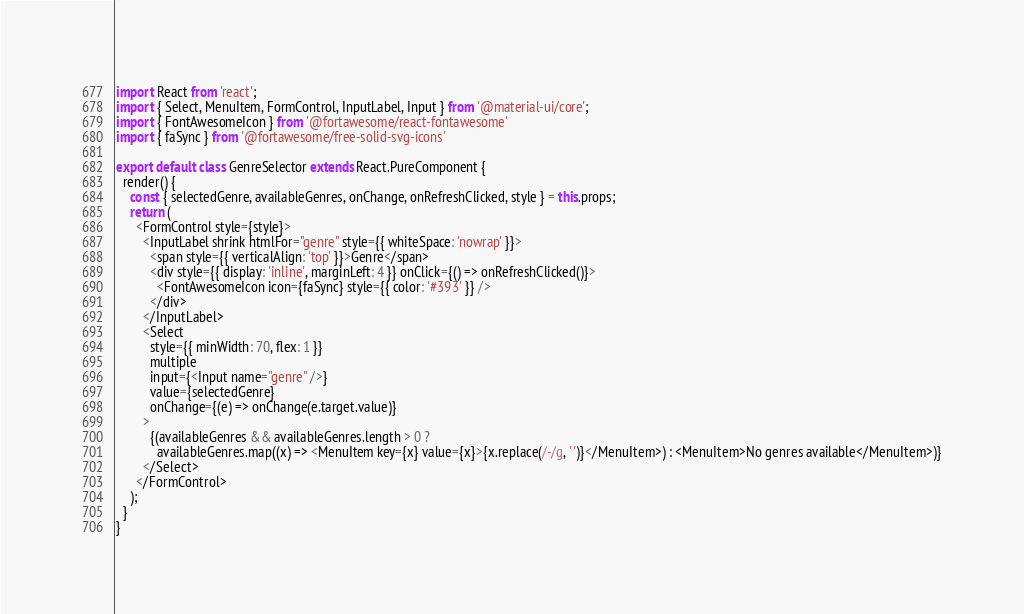<code> <loc_0><loc_0><loc_500><loc_500><_JavaScript_>import React from 'react';
import { Select, MenuItem, FormControl, InputLabel, Input } from '@material-ui/core';
import { FontAwesomeIcon } from '@fortawesome/react-fontawesome'
import { faSync } from '@fortawesome/free-solid-svg-icons'

export default class GenreSelector extends React.PureComponent {
  render() {
    const { selectedGenre, availableGenres, onChange, onRefreshClicked, style } = this.props;
    return (
      <FormControl style={style}>
        <InputLabel shrink htmlFor="genre" style={{ whiteSpace: 'nowrap' }}>
          <span style={{ verticalAlign: 'top' }}>Genre</span>
          <div style={{ display: 'inline', marginLeft: 4 }} onClick={() => onRefreshClicked()}>
            <FontAwesomeIcon icon={faSync} style={{ color: '#393' }} />
          </div>
        </InputLabel>
        <Select
          style={{ minWidth: 70, flex: 1 }}
          multiple
          input={<Input name="genre" />}
          value={selectedGenre}
          onChange={(e) => onChange(e.target.value)}
        >
          {(availableGenres && availableGenres.length > 0 ?
            availableGenres.map((x) => <MenuItem key={x} value={x}>{x.replace(/-/g, ' ')}</MenuItem>) : <MenuItem>No genres available</MenuItem>)}
        </Select>
      </FormControl>
    );
  }
}
</code> 